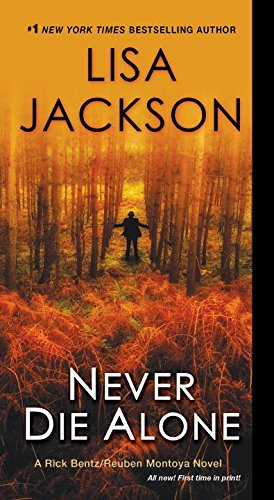Who is the author of this book? The author of the book depicted in the image is Lisa Jackson, a well-known writer renowned for her thrilling and suspenseful novels. 